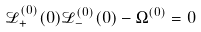<formula> <loc_0><loc_0><loc_500><loc_500>\mathcal { L } _ { + } ^ { ( 0 ) } ( 0 ) \mathcal { L } _ { - } ^ { ( 0 ) } ( 0 ) - \Omega ^ { ( 0 ) } = 0</formula> 